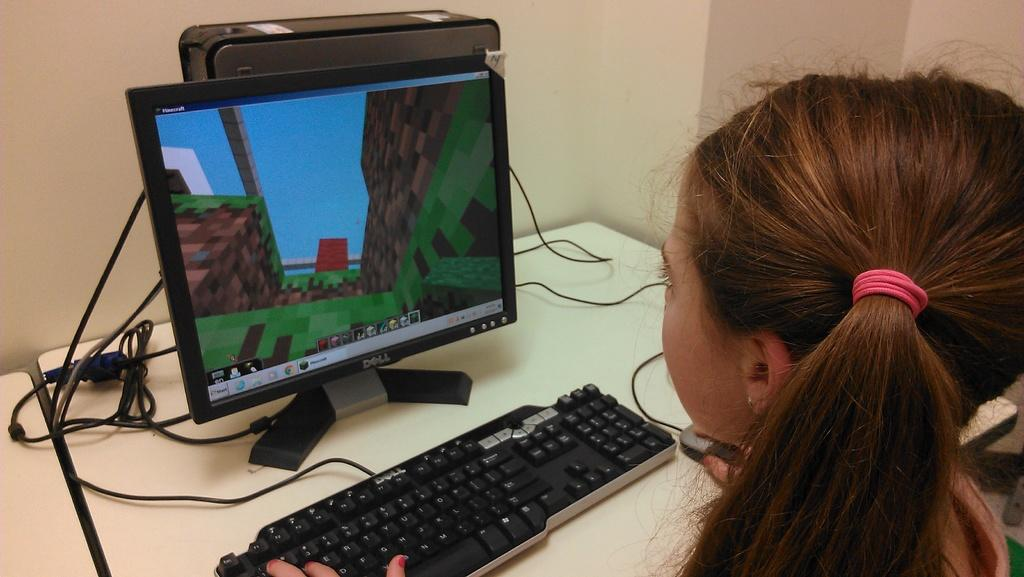<image>
Write a terse but informative summary of the picture. A girl sits at a Dell computer that is on. 